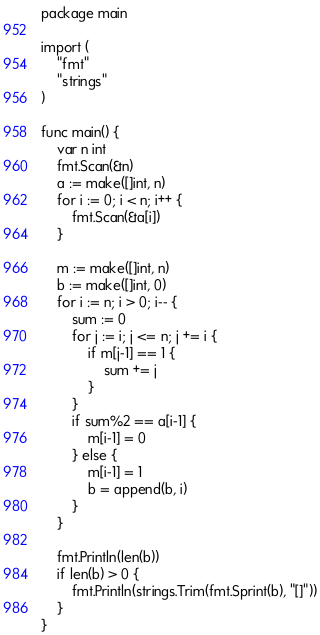Convert code to text. <code><loc_0><loc_0><loc_500><loc_500><_Go_>package main

import (
	"fmt"
	"strings"
)

func main() {
	var n int
	fmt.Scan(&n)
	a := make([]int, n)
	for i := 0; i < n; i++ {
		fmt.Scan(&a[i])
	}

	m := make([]int, n)
	b := make([]int, 0)
	for i := n; i > 0; i-- {
		sum := 0
		for j := i; j <= n; j += i {
			if m[j-1] == 1 {
				sum += j
			}
		}
		if sum%2 == a[i-1] {
			m[i-1] = 0
		} else {
			m[i-1] = 1
			b = append(b, i)
		}
	}

	fmt.Println(len(b))
	if len(b) > 0 {
		fmt.Println(strings.Trim(fmt.Sprint(b), "[]"))
	}
}
</code> 